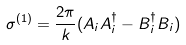<formula> <loc_0><loc_0><loc_500><loc_500>\sigma ^ { ( 1 ) } = \frac { 2 \pi } k ( A _ { i } A ^ { \dag } _ { i } - B ^ { \dag } _ { i } B _ { i } )</formula> 